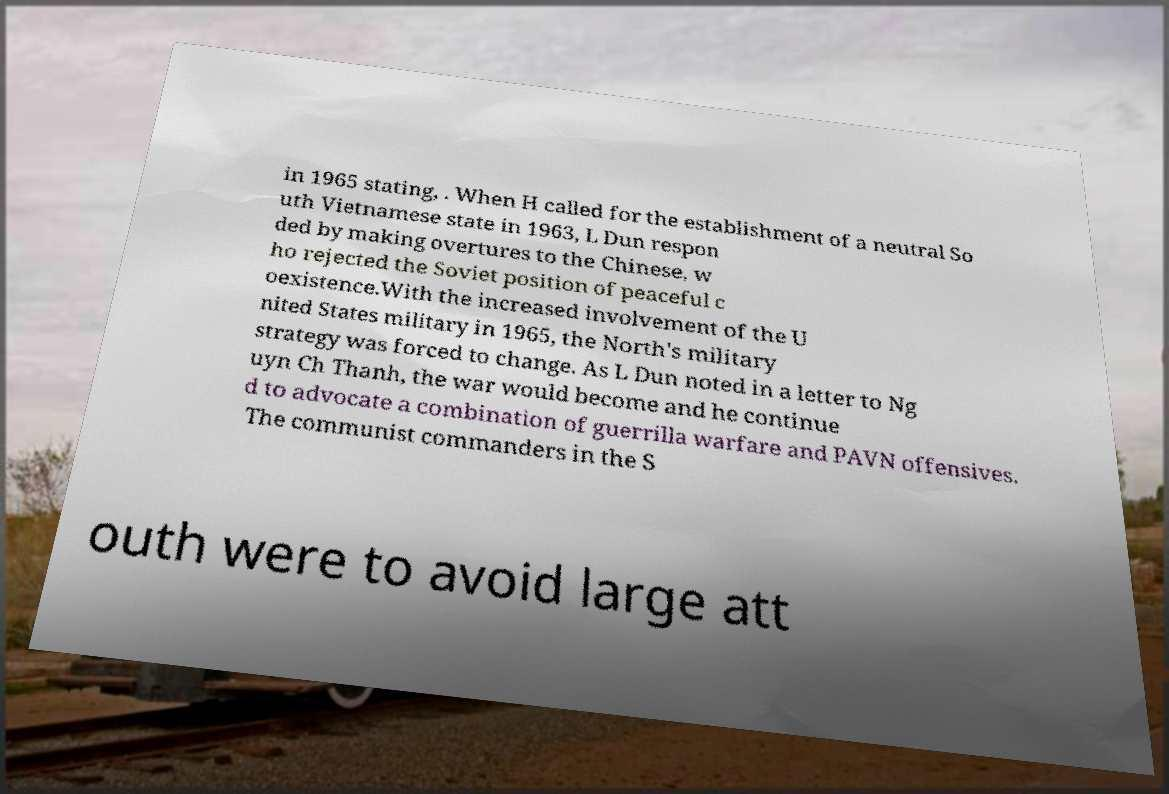There's text embedded in this image that I need extracted. Can you transcribe it verbatim? in 1965 stating, . When H called for the establishment of a neutral So uth Vietnamese state in 1963, L Dun respon ded by making overtures to the Chinese, w ho rejected the Soviet position of peaceful c oexistence.With the increased involvement of the U nited States military in 1965, the North's military strategy was forced to change. As L Dun noted in a letter to Ng uyn Ch Thanh, the war would become and he continue d to advocate a combination of guerrilla warfare and PAVN offensives. The communist commanders in the S outh were to avoid large att 